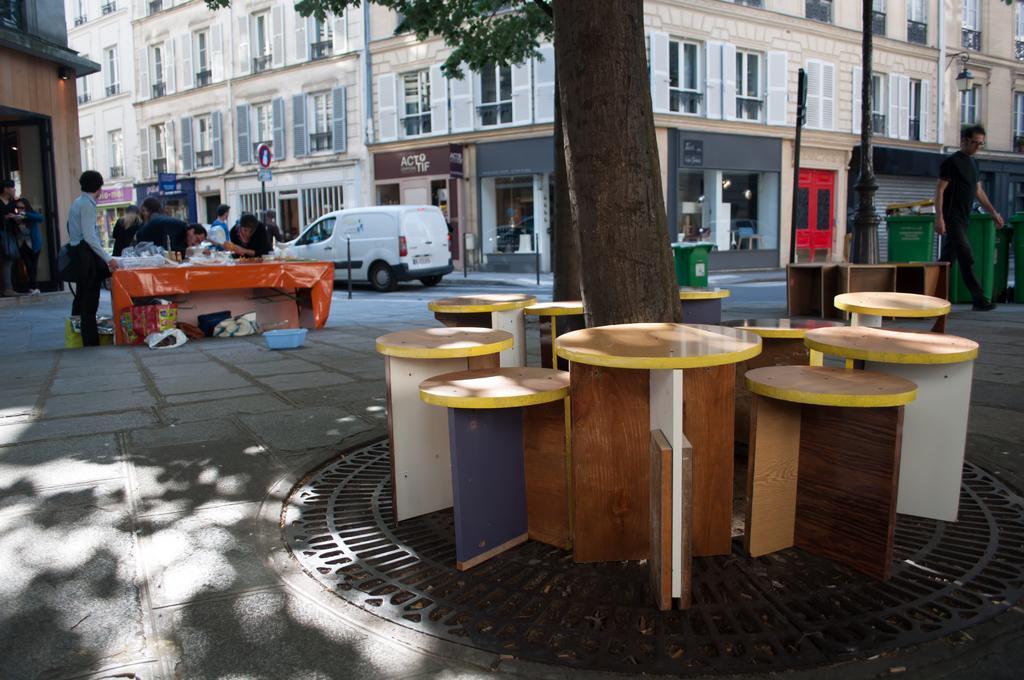Please provide a concise description of this image. In this image I can see a person is walking on the right side of the image. There are two bins just beside this person. In the background there is a building and road. On the road there is a white color car. On the left side of the image I can see few people are standing just beside a table. In the middle of the image I can see a tree and few chairs are arranged around the trunk. 